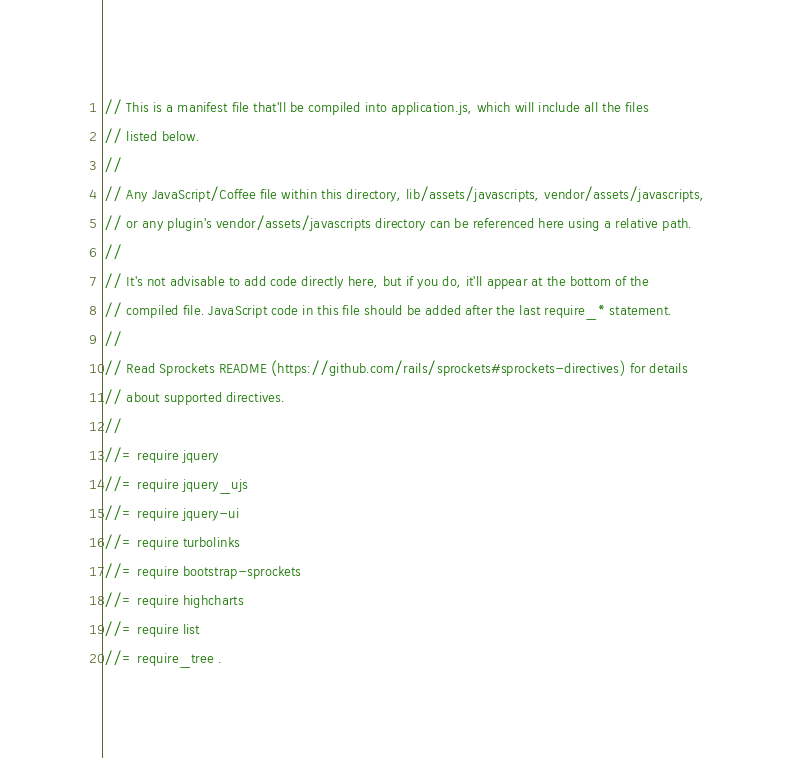Convert code to text. <code><loc_0><loc_0><loc_500><loc_500><_JavaScript_>// This is a manifest file that'll be compiled into application.js, which will include all the files
// listed below.
//
// Any JavaScript/Coffee file within this directory, lib/assets/javascripts, vendor/assets/javascripts,
// or any plugin's vendor/assets/javascripts directory can be referenced here using a relative path.
//
// It's not advisable to add code directly here, but if you do, it'll appear at the bottom of the
// compiled file. JavaScript code in this file should be added after the last require_* statement.
//
// Read Sprockets README (https://github.com/rails/sprockets#sprockets-directives) for details
// about supported directives.
//
//= require jquery
//= require jquery_ujs
//= require jquery-ui
//= require turbolinks
//= require bootstrap-sprockets
//= require highcharts
//= require list
//= require_tree .
</code> 